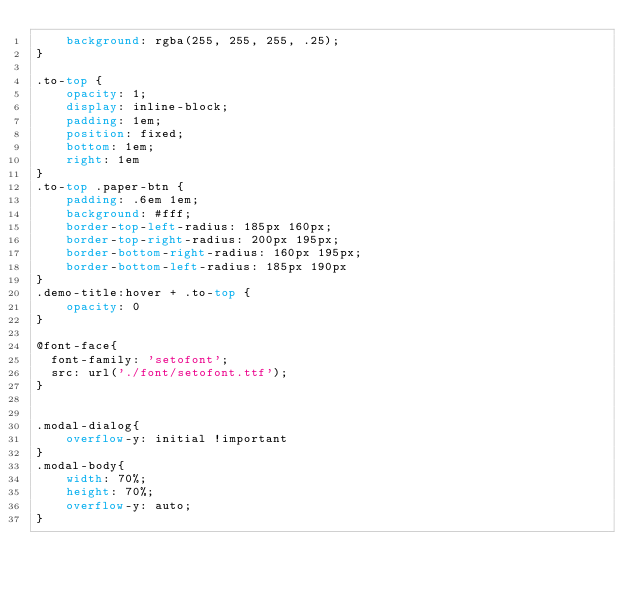Convert code to text. <code><loc_0><loc_0><loc_500><loc_500><_CSS_>    background: rgba(255, 255, 255, .25);
}

.to-top {
    opacity: 1;
    display: inline-block;
    padding: 1em;
    position: fixed;
    bottom: 1em;
    right: 1em
}
.to-top .paper-btn {
    padding: .6em 1em;
    background: #fff;
    border-top-left-radius: 185px 160px;
    border-top-right-radius: 200px 195px;
    border-bottom-right-radius: 160px 195px;
    border-bottom-left-radius: 185px 190px
}
.demo-title:hover + .to-top {
    opacity: 0
}

@font-face{
	font-family: 'setofont';
	src: url('./font/setofont.ttf');
}


.modal-dialog{
    overflow-y: initial !important
}
.modal-body{
    width: 70%;
    height: 70%;
    overflow-y: auto;
}</code> 